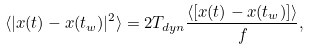<formula> <loc_0><loc_0><loc_500><loc_500>\langle | x ( t ) - x ( t _ { w } ) | ^ { 2 } \rangle = 2 T _ { d y n } \frac { \langle [ x ( t ) - x ( t _ { w } ) ] \rangle } { f } ,</formula> 